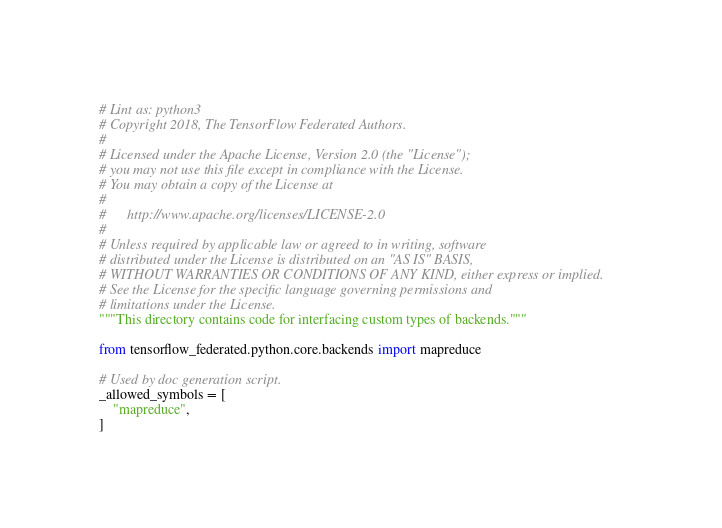Convert code to text. <code><loc_0><loc_0><loc_500><loc_500><_Python_># Lint as: python3
# Copyright 2018, The TensorFlow Federated Authors.
#
# Licensed under the Apache License, Version 2.0 (the "License");
# you may not use this file except in compliance with the License.
# You may obtain a copy of the License at
#
#      http://www.apache.org/licenses/LICENSE-2.0
#
# Unless required by applicable law or agreed to in writing, software
# distributed under the License is distributed on an "AS IS" BASIS,
# WITHOUT WARRANTIES OR CONDITIONS OF ANY KIND, either express or implied.
# See the License for the specific language governing permissions and
# limitations under the License.
"""This directory contains code for interfacing custom types of backends."""

from tensorflow_federated.python.core.backends import mapreduce

# Used by doc generation script.
_allowed_symbols = [
    "mapreduce",
]
</code> 